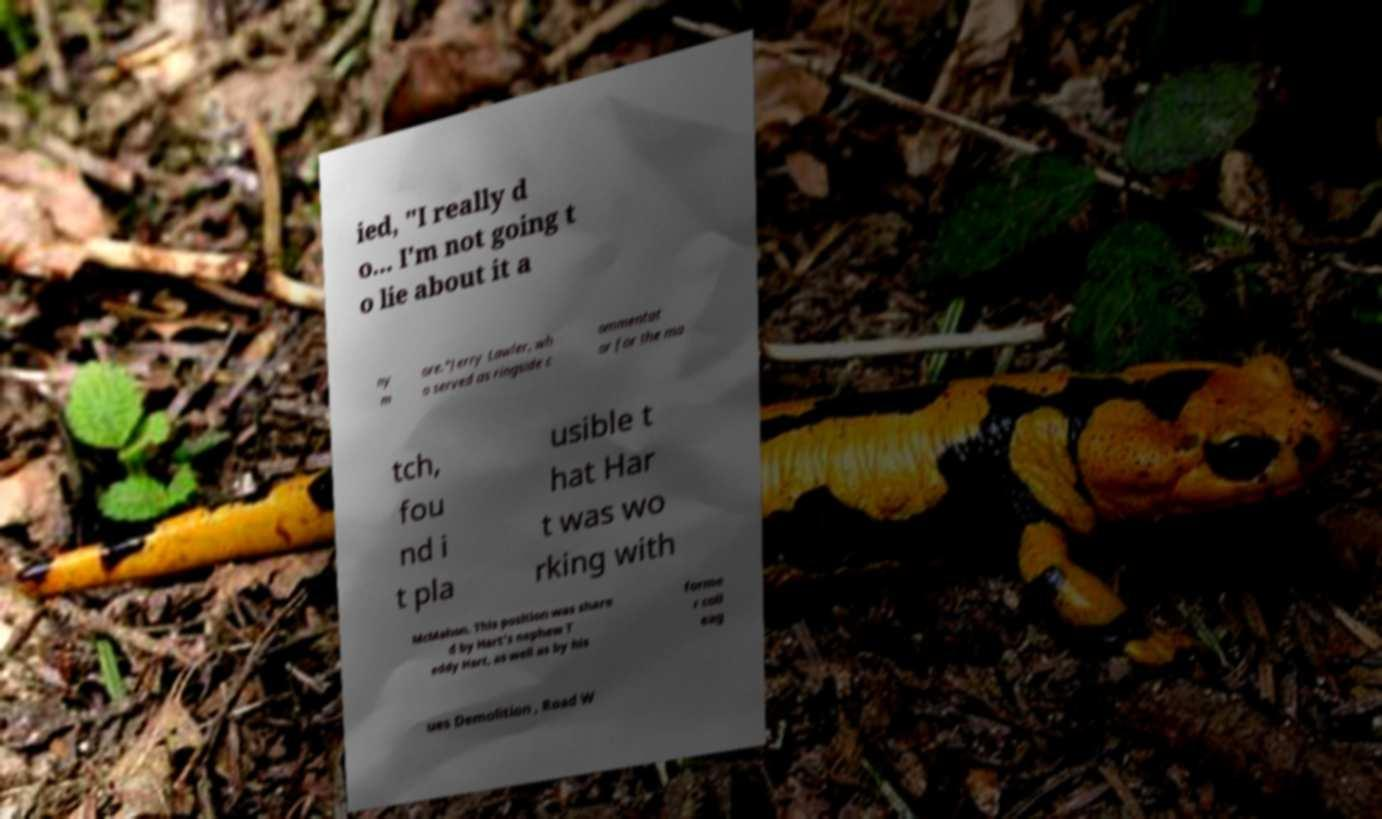There's text embedded in this image that I need extracted. Can you transcribe it verbatim? ied, "I really d o... I'm not going t o lie about it a ny m ore."Jerry Lawler, wh o served as ringside c ommentat or for the ma tch, fou nd i t pla usible t hat Har t was wo rking with McMahon. This position was share d by Hart's nephew T eddy Hart, as well as by his forme r coll eag ues Demolition , Road W 